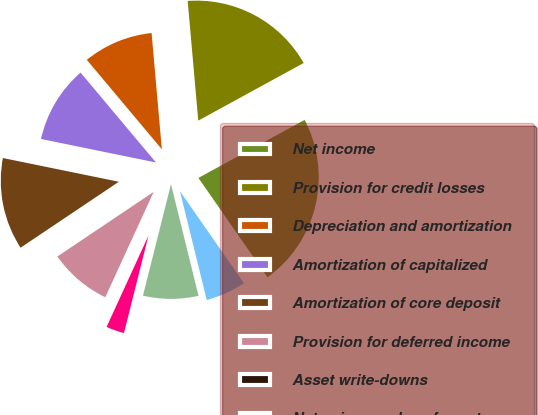Convert chart to OTSL. <chart><loc_0><loc_0><loc_500><loc_500><pie_chart><fcel>Net income<fcel>Provision for credit losses<fcel>Depreciation and amortization<fcel>Amortization of capitalized<fcel>Amortization of core deposit<fcel>Provision for deferred income<fcel>Asset write-downs<fcel>Net gain on sales of assets<fcel>Net change in accrued interest<fcel>Net change in other accrued<nl><fcel>23.29%<fcel>18.44%<fcel>9.71%<fcel>10.68%<fcel>12.62%<fcel>8.74%<fcel>0.01%<fcel>2.92%<fcel>7.77%<fcel>5.83%<nl></chart> 